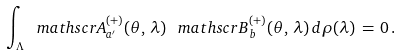Convert formula to latex. <formula><loc_0><loc_0><loc_500><loc_500>\int _ { \Lambda } { \ m a t h s c r A } ^ { ( + ) } _ { a ^ { \prime } } ( \theta , \, \lambda ) \, { \ m a t h s c r B } ^ { ( + ) } _ { b } ( \theta , \, \lambda ) \, d \rho ( \lambda ) \, = \, 0 \, .</formula> 